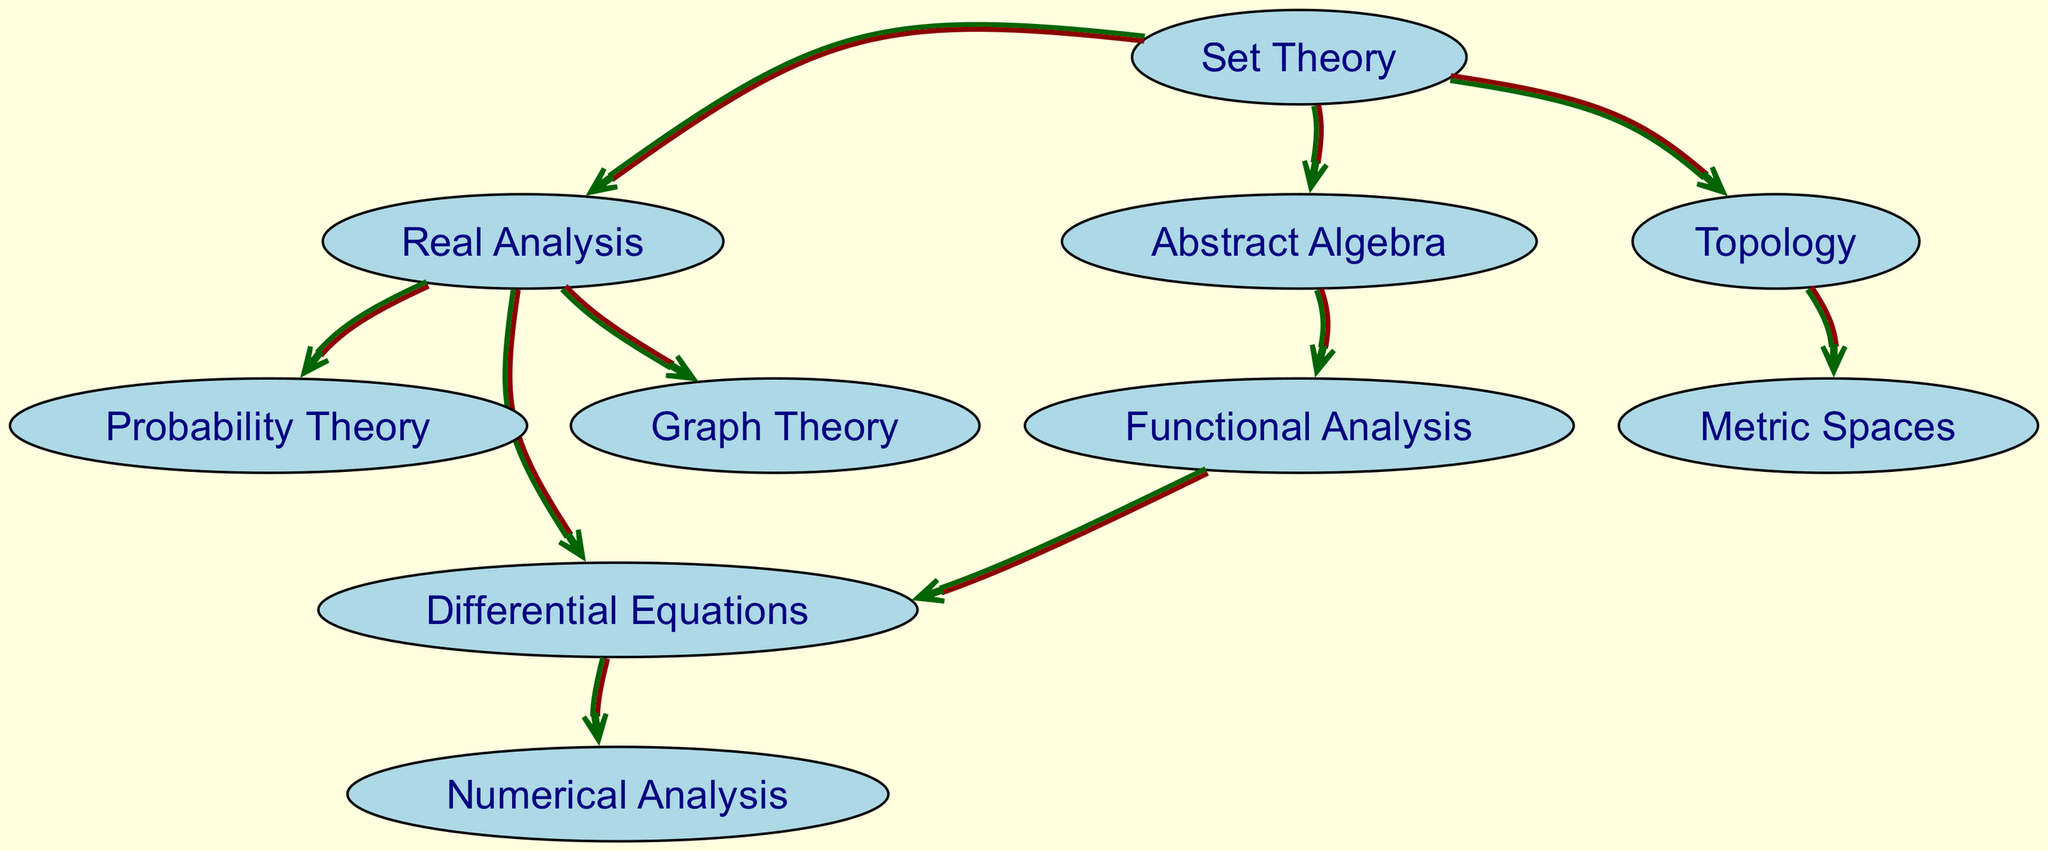What are the total number of nodes in the diagram? By counting the entries in the 'nodes' section of the data, there are 10 unique mathematical theories represented as nodes.
Answer: 10 Which theory is considered the base of the hierarchy in this diagram? The diagram shows that Set Theory has edges pointing to Real Analysis, Abstract Algebra, and Topology, indicating it is foundational to these theories.
Answer: Set Theory What is the direct connection of Real Analysis in the diagram? Real Analysis has direct edges leading to Differential Equations, Probability Theory, and Graph Theory. This shows its influence on these areas.
Answer: Differential Equations, Probability Theory, Graph Theory How many edges are there linking Abstract Algebra to other theories? There is one direct edge from Abstract Algebra to Functional Analysis, indicating it has a direct relationship with this theory.
Answer: 1 From which theory can you find a connection to both Topology and Functional Analysis? Tracing the edges, Topology connects to Metric Spaces and goes down to Functional Analysis via Abstract Algebra, while Functional Analysis itself also leads to Differential Equations.
Answer: Topology Which mathematical theory has the most outgoing connections? By examining outgoing edges, Real Analysis has the highest number of connections, leading to three theories: Differential Equations, Probability Theory, and Graph Theory.
Answer: Real Analysis Are there any theories that connect directly to Differential Equations? Yes, Differential Equations has one outgoing edge leading to Numerical Analysis, establishing a direct connection.
Answer: Numerical Analysis What is the relationship between Metric Spaces and Topology in the graph? Metric Spaces is a node that has an incoming edge from Topology, indicating that Metric Spaces is a subfield derived from Topology.
Answer: Incoming edge from Topology How many theories are interconnected through edges in the diagram? Each edge represents a connection among theories, and with a total of 9 edges present, this reflects the interconnectivity among the fields.
Answer: 9 Which theory leads into Functional Analysis in the graph? The directed edge from Abstract Algebra shows that this theory leads into Functional Analysis, indicating a relationship between the two.
Answer: Abstract Algebra 